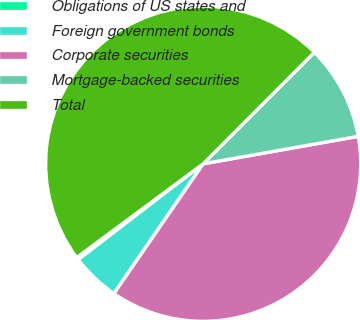Convert chart to OTSL. <chart><loc_0><loc_0><loc_500><loc_500><pie_chart><fcel>Obligations of US states and<fcel>Foreign government bonds<fcel>Corporate securities<fcel>Mortgage-backed securities<fcel>Total<nl><fcel>0.26%<fcel>5.0%<fcel>37.38%<fcel>9.73%<fcel>47.63%<nl></chart> 